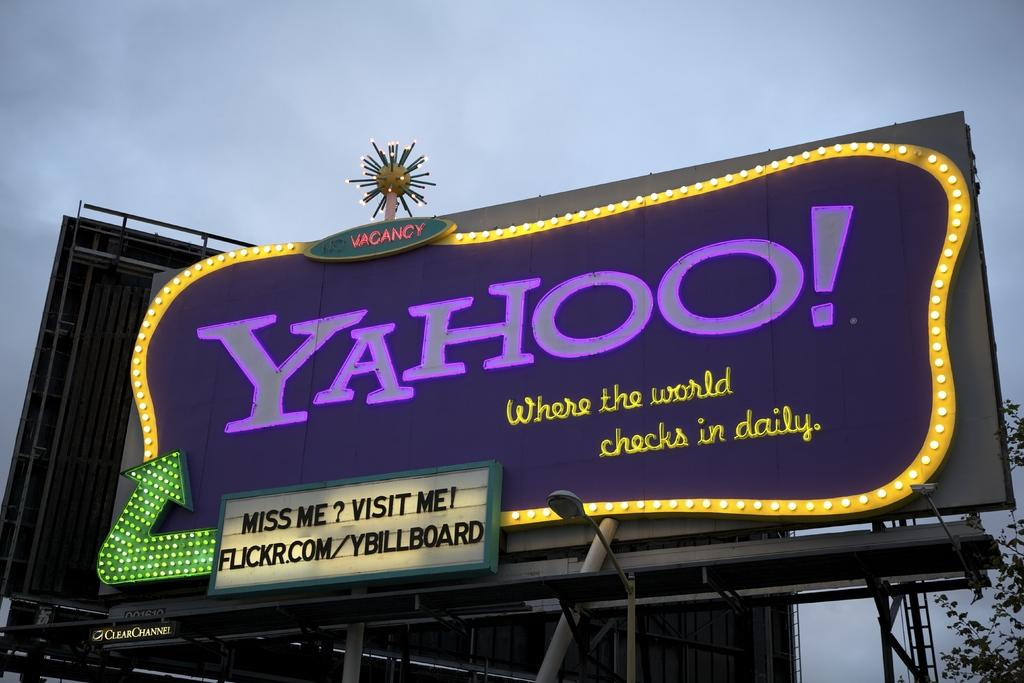<image>
Provide a brief description of the given image. A billboard displays Yahoo in purple letters surrounded by a yellow border. 